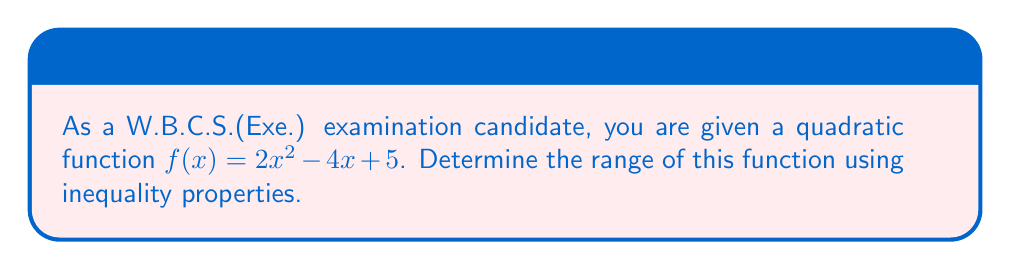Show me your answer to this math problem. Let's approach this step-by-step:

1) The general form of a quadratic function is $f(x) = ax^2 + bx + c$, where $a \neq 0$.

2) In this case, $a = 2$, $b = -4$, and $c = 5$.

3) To find the range, we need to find the vertex of the parabola. The x-coordinate of the vertex is given by $x = -\frac{b}{2a}$.

4) Substituting our values:
   $x = -\frac{-4}{2(2)} = \frac{4}{4} = 1$

5) To find the y-coordinate of the vertex, we substitute $x = 1$ into the original function:
   $f(1) = 2(1)^2 - 4(1) + 5 = 2 - 4 + 5 = 3$

6) So, the vertex is at the point (1, 3).

7) Since $a > 0$, the parabola opens upward, and the vertex represents the minimum point of the function.

8) Therefore, we can express the range as an inequality:
   $f(x) \geq 3$ for all real numbers $x$.

9) In set notation, the range is $\{y \in \mathbb{R} : y \geq 3\}$.

This approach uses the properties of inequalities and the characteristics of quadratic functions to determine the range.
Answer: $\{y \in \mathbb{R} : y \geq 3\}$ 